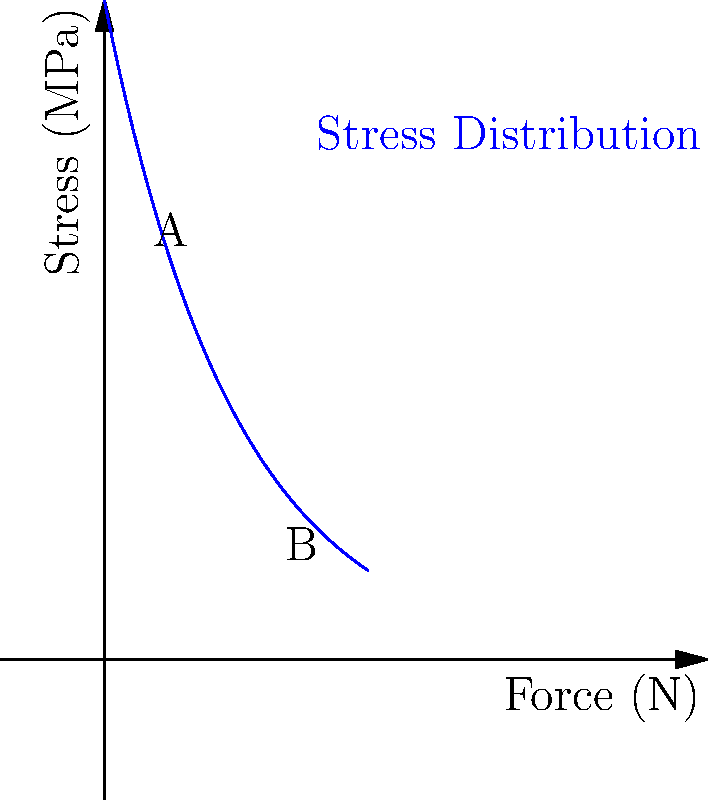In the exoskeleton design for space exploration, the stress distribution curve is shown above. If the maximum allowable stress for the material is 30 MPa, what is the maximum force (in Newtons) that can be safely applied to the exoskeleton based on this stress distribution? To find the maximum safe force, we need to analyze the stress distribution curve:

1. The y-axis represents stress in MPa, and the x-axis represents force in N.
2. The maximum allowable stress is given as 30 MPa.
3. We need to find the force (x-value) corresponding to 30 MPa on the y-axis.

4. The stress distribution follows an exponential decay function:
   $$\sigma = \sigma_0 e^{-F/F_0}$$
   where $\sigma$ is stress, $F$ is force, and $\sigma_0$ and $F_0$ are constants.

5. From the graph, we can estimate that $\sigma_0 \approx 50$ MPa and $F_0 \approx 10$ N.

6. Substituting the maximum allowable stress:
   $$30 = 50 e^{-F/10}$$

7. Solving for F:
   $$\ln(30/50) = -F/10$$
   $$F = -10 \ln(0.6) \approx 5.1 \text{ N}$$

8. Therefore, the maximum safe force is approximately 5.1 N.

This analysis demonstrates how mathematical models and graphical representations can be used to solve engineering problems in space exploration, emphasizing the logical approach to character development in science fiction writing.
Answer: 5.1 N 